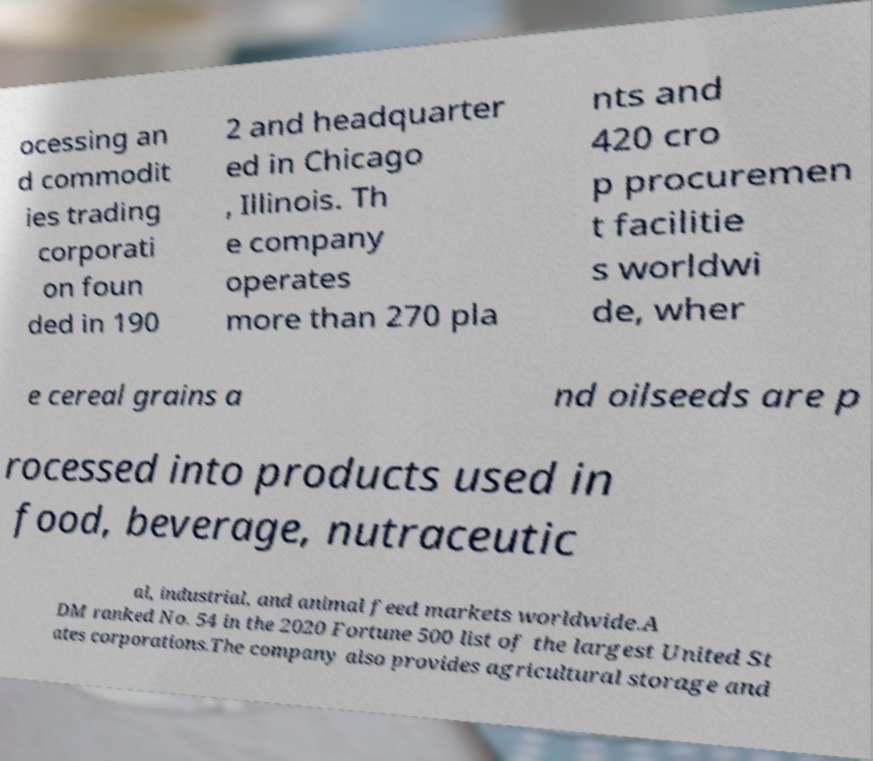Please identify and transcribe the text found in this image. ocessing an d commodit ies trading corporati on foun ded in 190 2 and headquarter ed in Chicago , Illinois. Th e company operates more than 270 pla nts and 420 cro p procuremen t facilitie s worldwi de, wher e cereal grains a nd oilseeds are p rocessed into products used in food, beverage, nutraceutic al, industrial, and animal feed markets worldwide.A DM ranked No. 54 in the 2020 Fortune 500 list of the largest United St ates corporations.The company also provides agricultural storage and 